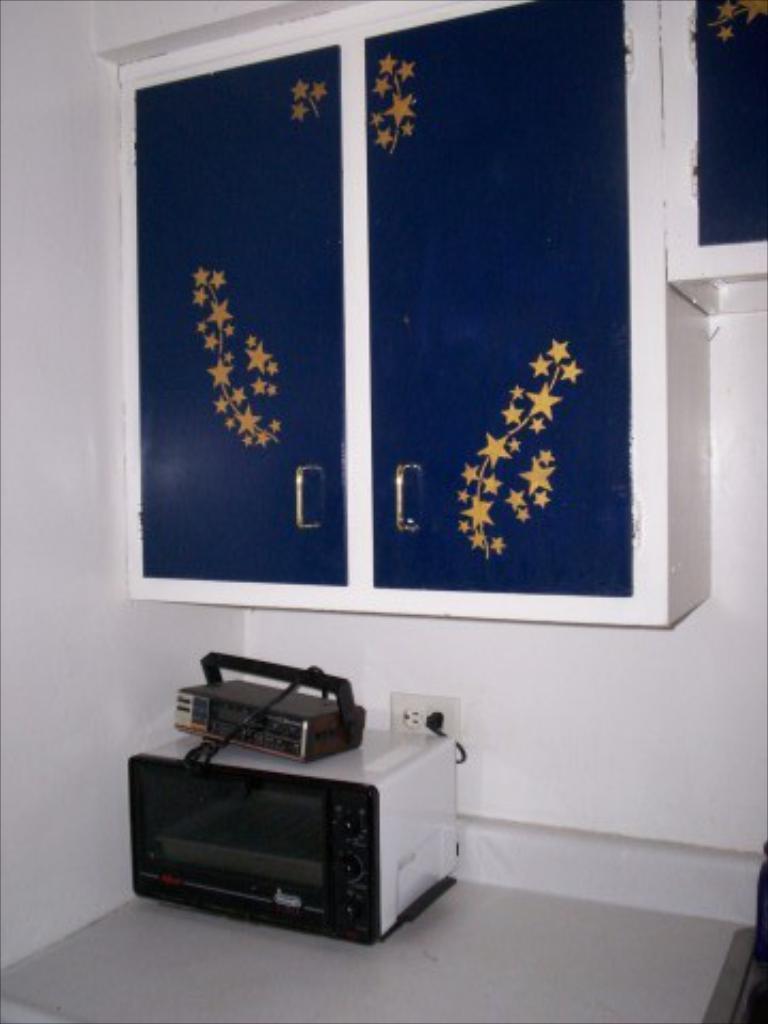Can you describe this image briefly? In this image I can see some device on the floor. In the background, I can see the cupboards on the wall. 